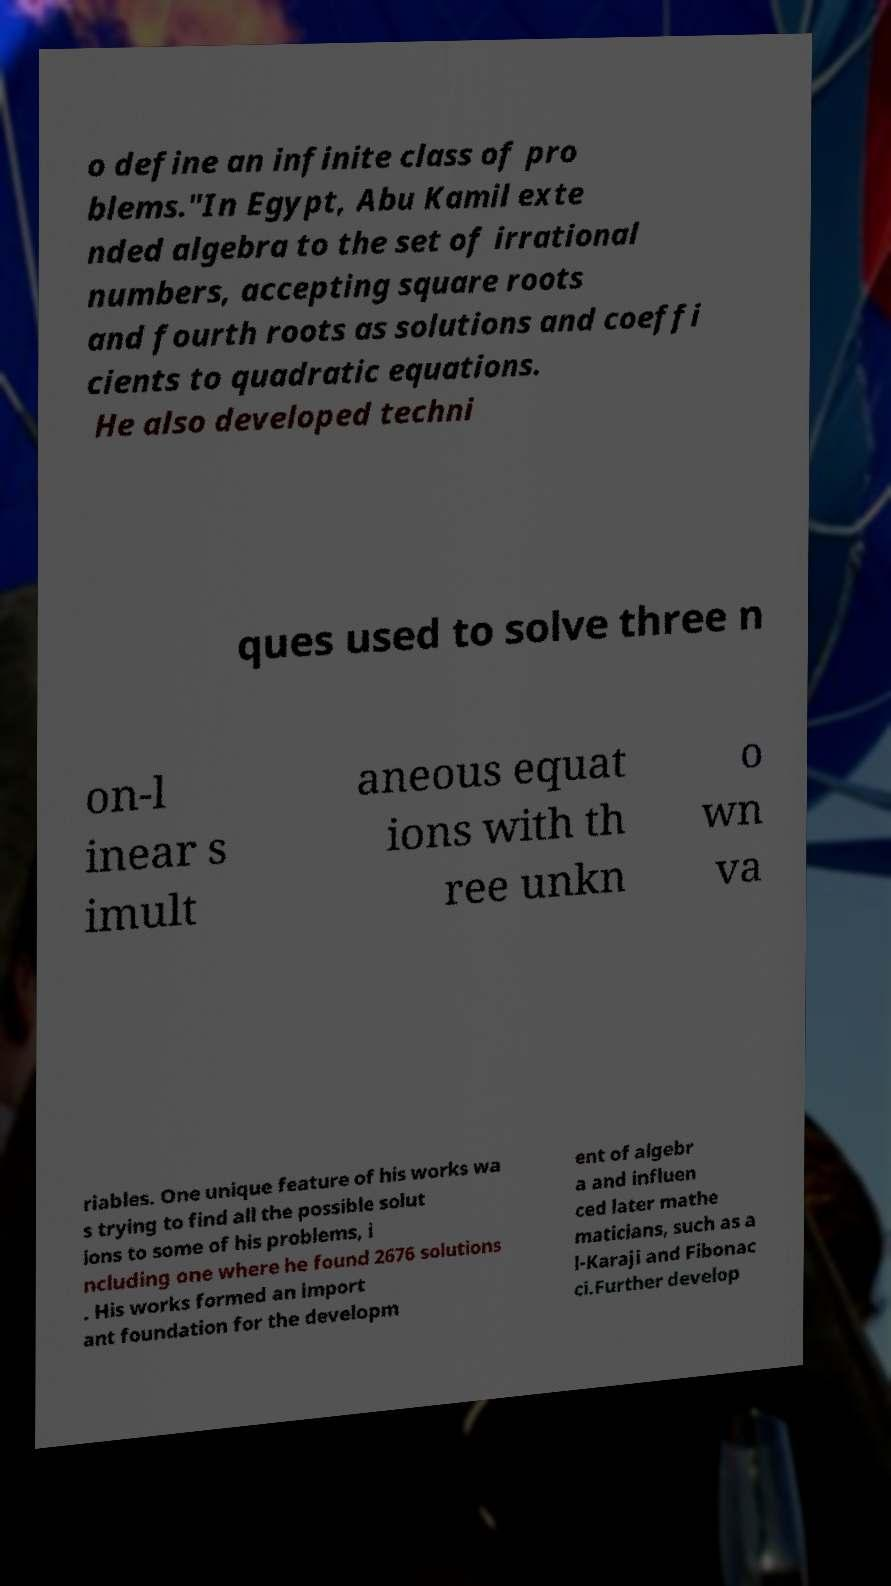Can you read and provide the text displayed in the image?This photo seems to have some interesting text. Can you extract and type it out for me? o define an infinite class of pro blems."In Egypt, Abu Kamil exte nded algebra to the set of irrational numbers, accepting square roots and fourth roots as solutions and coeffi cients to quadratic equations. He also developed techni ques used to solve three n on-l inear s imult aneous equat ions with th ree unkn o wn va riables. One unique feature of his works wa s trying to find all the possible solut ions to some of his problems, i ncluding one where he found 2676 solutions . His works formed an import ant foundation for the developm ent of algebr a and influen ced later mathe maticians, such as a l-Karaji and Fibonac ci.Further develop 